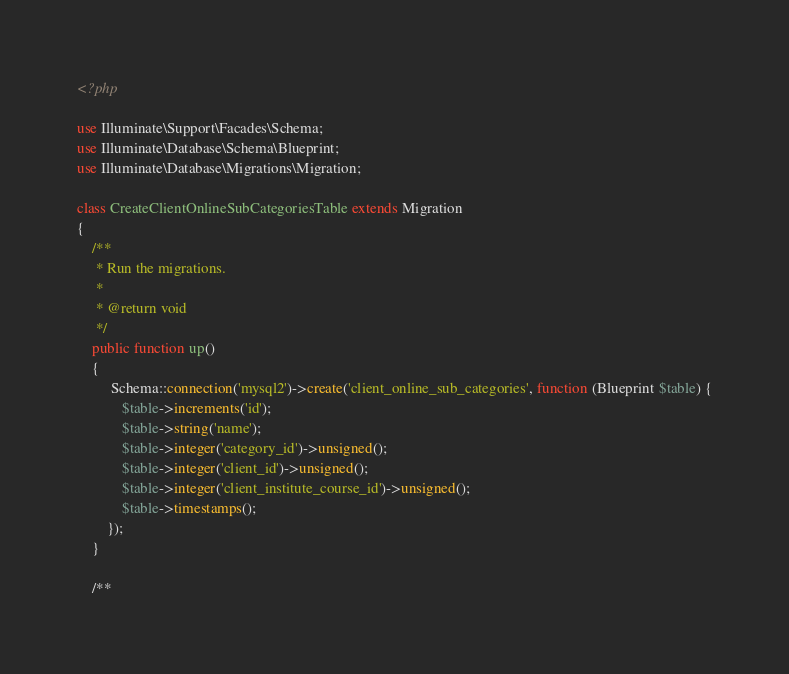Convert code to text. <code><loc_0><loc_0><loc_500><loc_500><_PHP_><?php

use Illuminate\Support\Facades\Schema;
use Illuminate\Database\Schema\Blueprint;
use Illuminate\Database\Migrations\Migration;

class CreateClientOnlineSubCategoriesTable extends Migration
{
    /**
     * Run the migrations.
     *
     * @return void
     */
    public function up()
    {
         Schema::connection('mysql2')->create('client_online_sub_categories', function (Blueprint $table) {
            $table->increments('id');
            $table->string('name');
            $table->integer('category_id')->unsigned();
            $table->integer('client_id')->unsigned();
            $table->integer('client_institute_course_id')->unsigned();
            $table->timestamps();
        });
    }

    /**</code> 